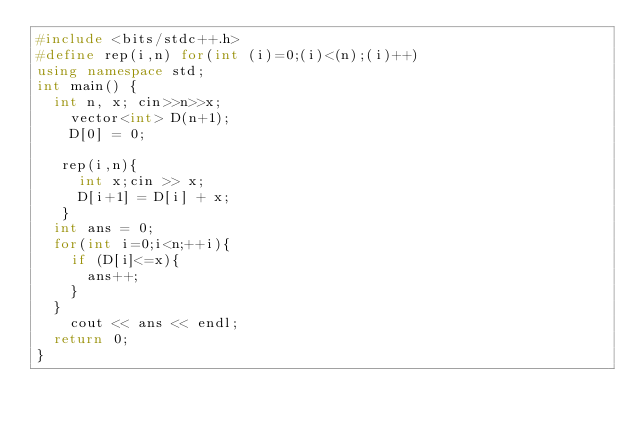Convert code to text. <code><loc_0><loc_0><loc_500><loc_500><_C++_>#include <bits/stdc++.h>
#define rep(i,n) for(int (i)=0;(i)<(n);(i)++)
using namespace std;
int main() {
	int n, x; cin>>n>>x;
    vector<int> D(n+1);
    D[0] = 0;
  
   rep(i,n){
     int x;cin >> x;
     D[i+1] = D[i] + x;
   }
  int ans = 0;
  for(int i=0;i<n;++i){
    if (D[i]<=x){
      ans++;
    }
  }
    cout << ans << endl;
  return 0;
}</code> 